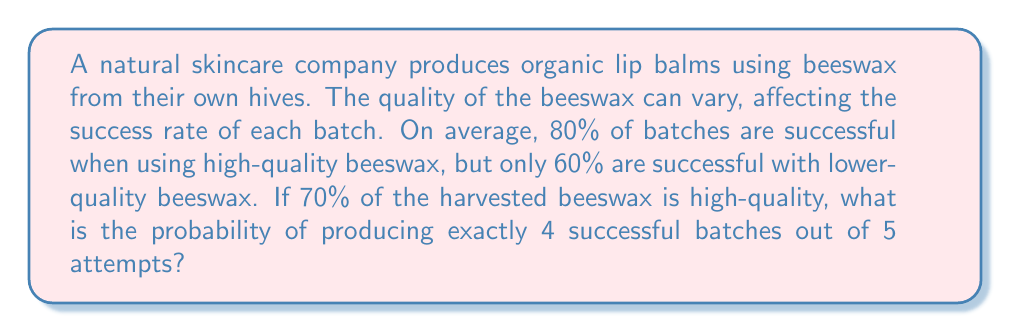Help me with this question. Let's approach this step-by-step using the law of total probability and the binomial distribution:

1) Let $H$ be the event of using high-quality beeswax, and $L$ be the event of using low-quality beeswax.
   $P(H) = 0.7$ and $P(L) = 1 - P(H) = 0.3$

2) Let $X$ be the number of successful batches out of 5 attempts.
   We need to find $P(X = 4)$

3) Using the law of total probability:
   $P(X = 4) = P(X = 4|H)P(H) + P(X = 4|L)P(L)$

4) For each case, we use the binomial distribution:
   $P(X = 4|H) = \binom{5}{4}(0.8)^4(0.2)^1$
   $P(X = 4|L) = \binom{5}{4}(0.6)^4(0.4)^1$

5) Calculating:
   $P(X = 4|H) = 5 \times 0.8^4 \times 0.2 = 0.4096$
   $P(X = 4|L) = 5 \times 0.6^4 \times 0.4 = 0.2592$

6) Substituting into the formula from step 3:
   $P(X = 4) = 0.4096 \times 0.7 + 0.2592 \times 0.3$
             $= 0.28672 + 0.07776$
             $= 0.36448$

Therefore, the probability of producing exactly 4 successful batches out of 5 attempts is 0.36448 or about 36.45%.
Answer: 0.36448 